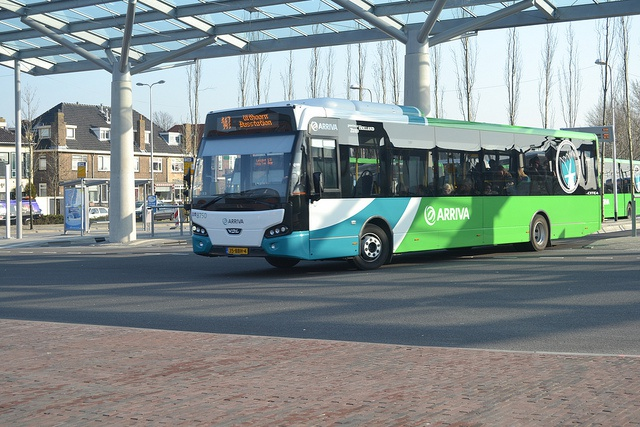Describe the objects in this image and their specific colors. I can see bus in beige, black, darkgray, lightgray, and gray tones, bus in beige, ivory, lightgreen, gray, and darkgray tones, car in beige, gray, darkgray, and black tones, car in beige, white, darkgray, and gray tones, and car in beige, gray, darkgray, lightgray, and black tones in this image. 